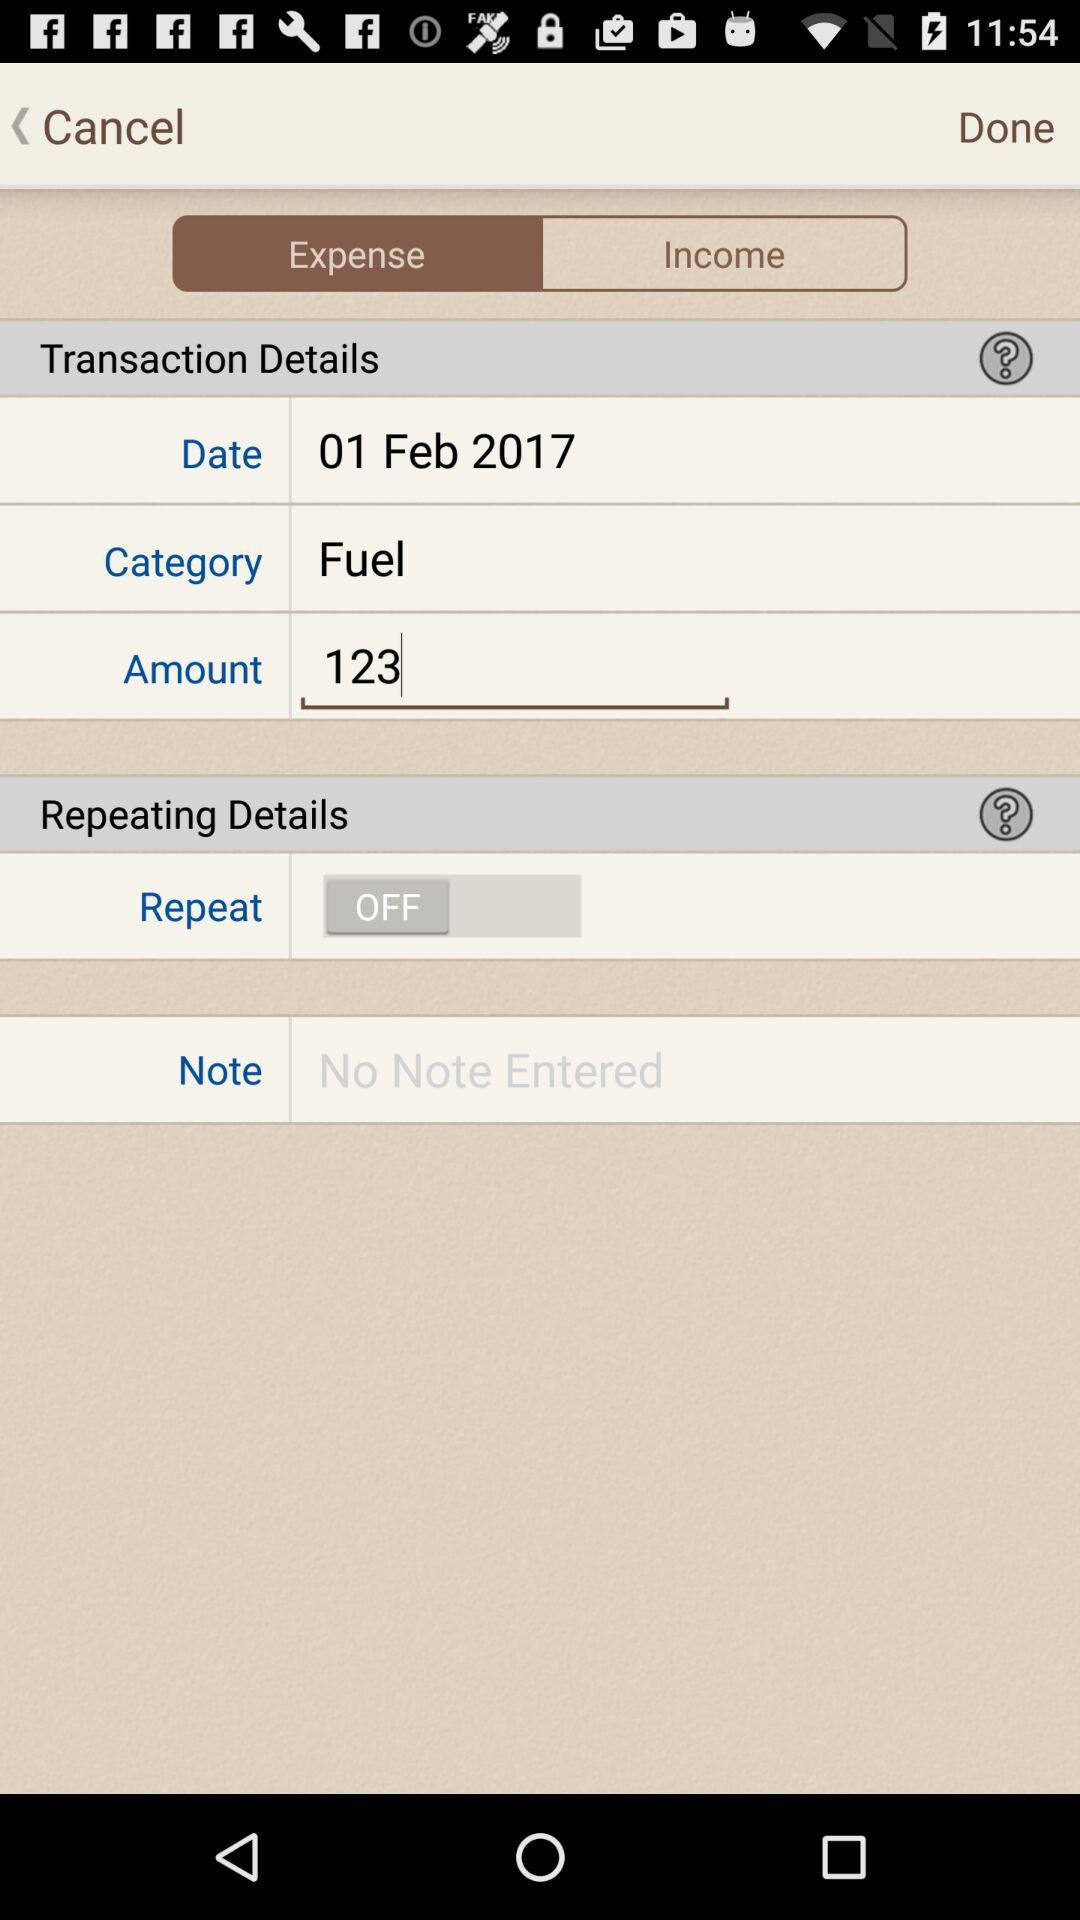What is the selected category? The selected category is "Fuel". 